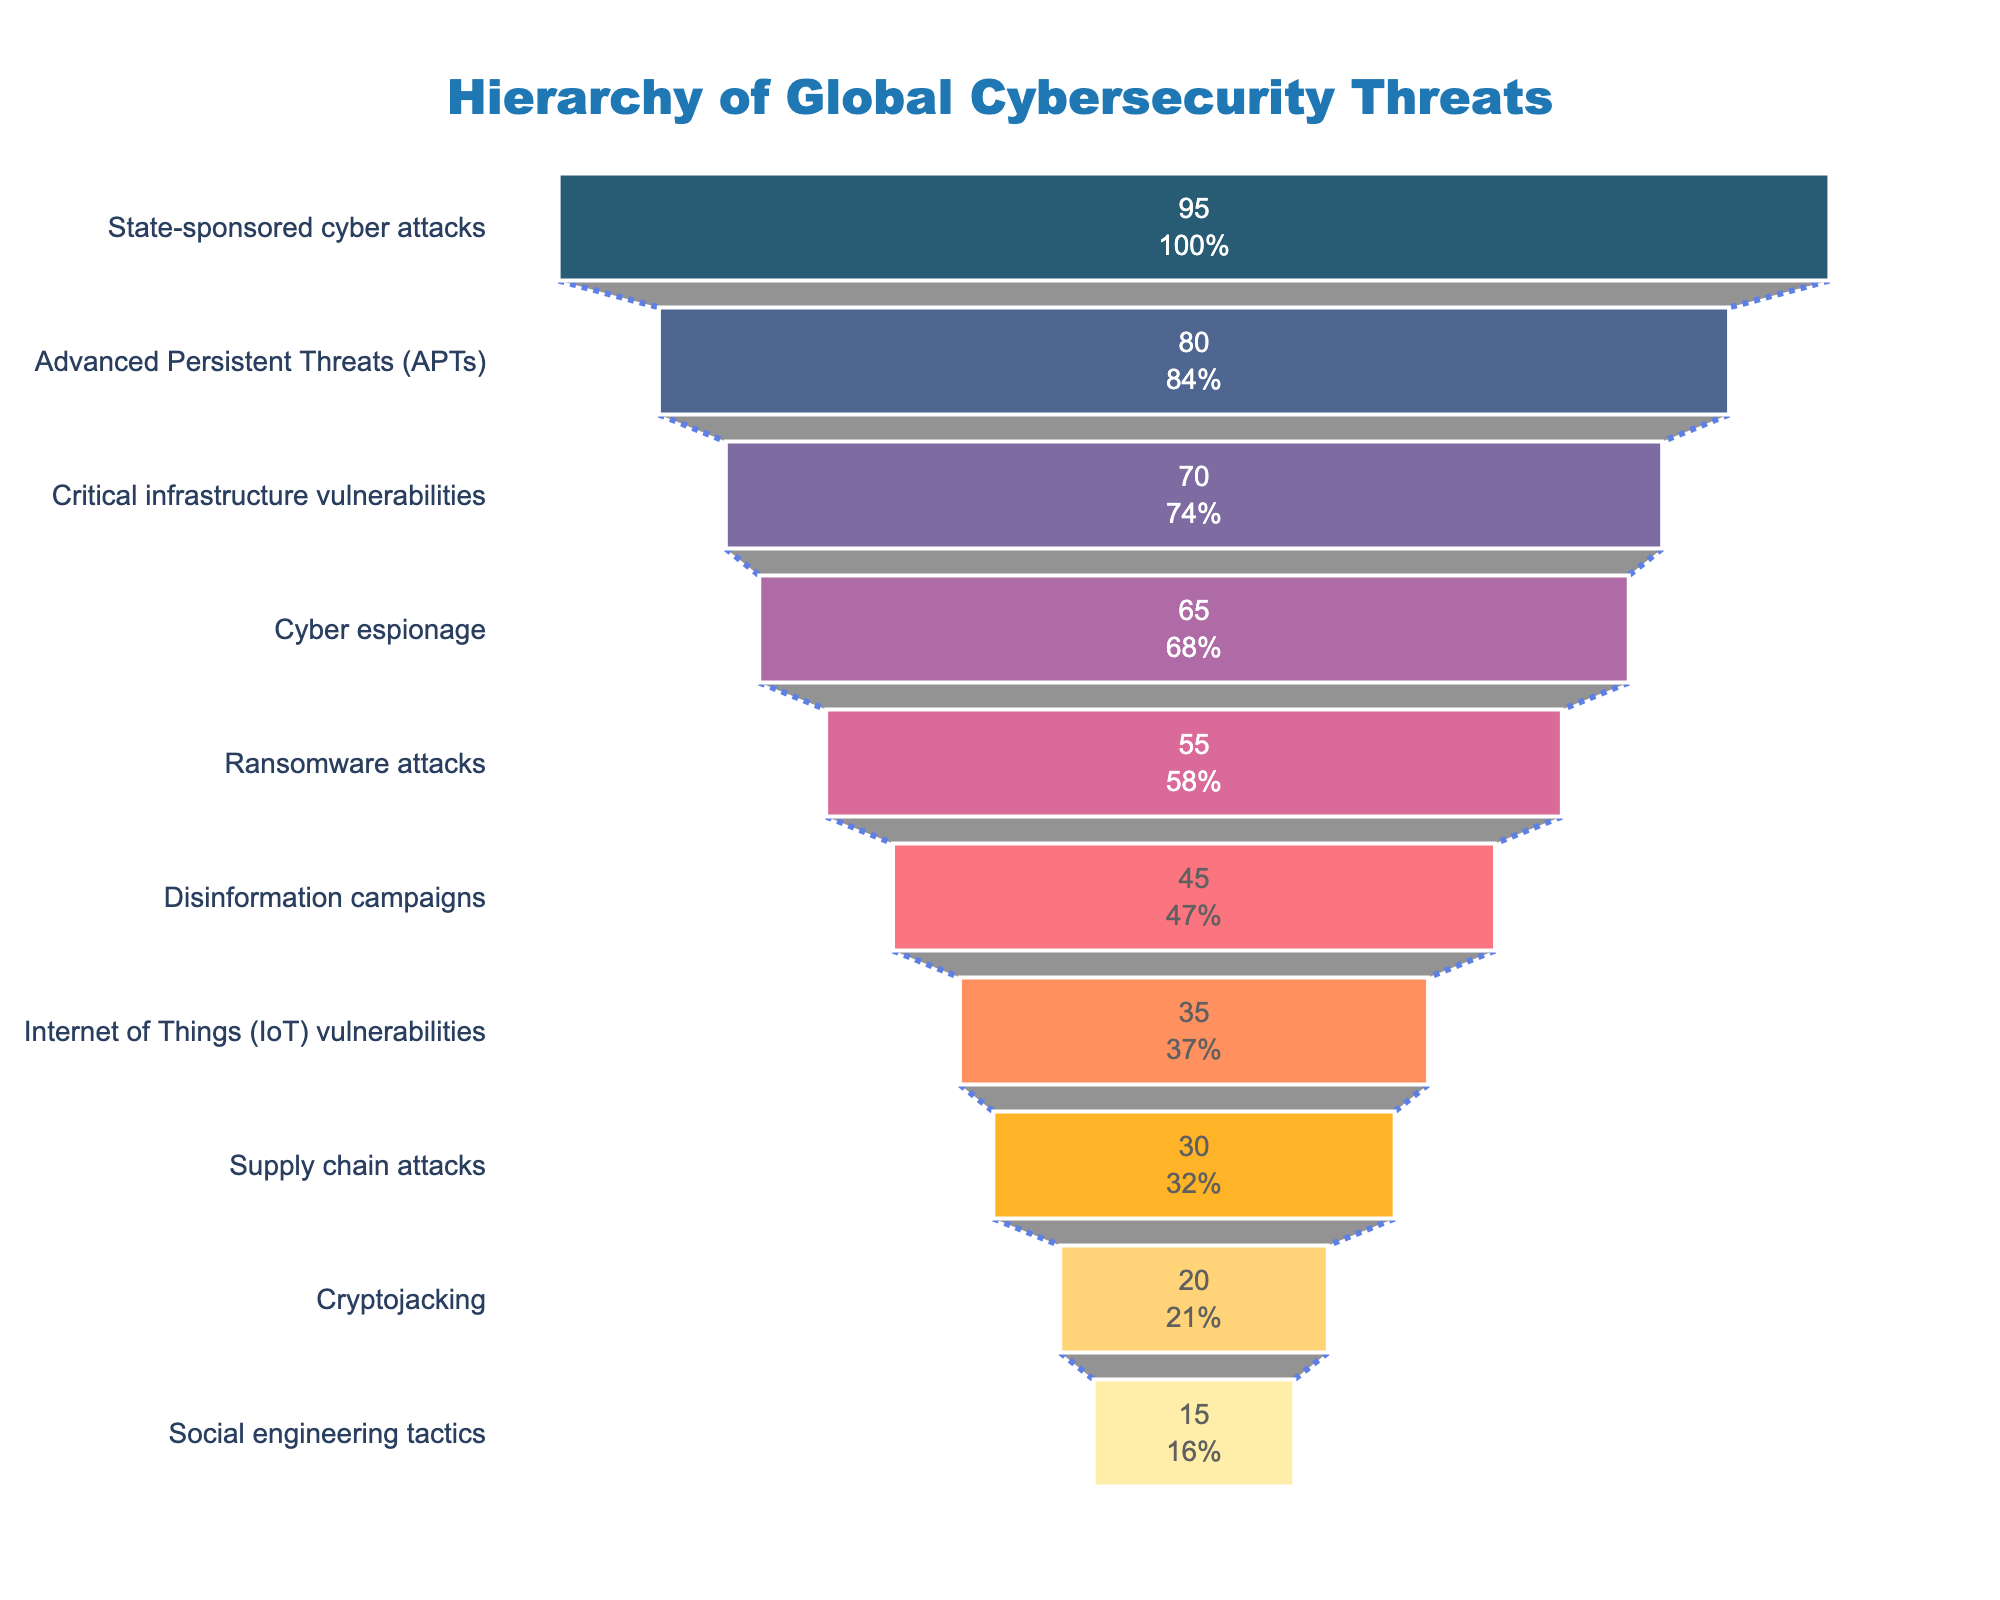What is the title of the figure? To determine the title, look at the top section of the figure where the main heading is usually displayed. The text placed there is the title.
Answer: "Hierarchy of Global Cybersecurity Threats" Which category has the highest impact on international relations? Identify the category at the widest part of the funnel at the top of the figure, as the chart is arranged in descending order of impact.
Answer: State-sponsored cyber attacks How many categories are listed in the funnel chart? Count the number of distinct sections in the funnel from top to bottom. Each section represents a category.
Answer: 10 What percentage of the total impact is attributed to Ransomware attacks? Locate the "Ransomware attacks" section, find the percentage value given inside the section.
Answer: 14.29% List the categories with an impact greater than 50. Identify and list all the categories whose impact values (indicated by the width) are greater than 50.
Answer: State-sponsored cyber attacks, Advanced Persistent Threats (APTs), Critical infrastructure vulnerabilities, Cyber espionage, Ransomware attacks What's the difference in impact between Social engineering tactics and Critical infrastructure vulnerabilities? Find the impact values for both categories (15 for Social engineering tactics and 70 for Critical infrastructure vulnerabilities), and calculate the difference by subtracting the smaller value from the larger value.
Answer: 55 Which category has the least impact on international relations? Locate the category at the narrowest part of the funnel at the bottom of the figure.
Answer: Social engineering tactics Compare the impact of Advanced Persistent Threats (APTs) to that of Cyber espionage. Which one is higher? Look for the sections corresponding to both categories, compare their impact values visually or by their numeric values listed.
Answer: Advanced Persistent Threats (APTs) How much more impact do Internet of Things (IoT) vulnerabilities have compared to Supply chain attacks? Locate the impact values for both categories (35 for IoT vulnerabilities, 30 for Supply chain attacks), subtract the impact of Supply chain attacks from IoT vulnerabilities to find the difference.
Answer: 5 What portion of the total impact is contributed by Disinformation campaigns and Cryptojacking combined? Sum the impact values of Disinformation campaigns (45) and Cryptojacking (20) and determine the combined portion by adding them  (45 + 20 = 65). Then express it as a percentage of the total impact (which is the sum of all impacts). The percentage would be (65 / Total Impact) * 100.
Answer: 16.85% 